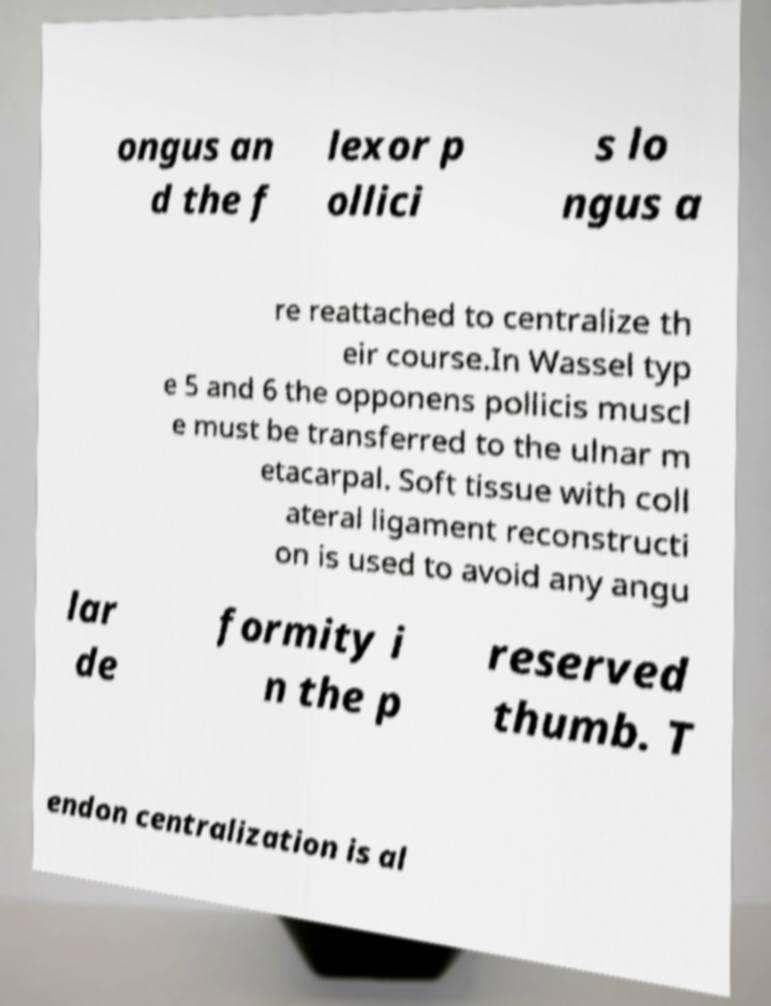I need the written content from this picture converted into text. Can you do that? ongus an d the f lexor p ollici s lo ngus a re reattached to centralize th eir course.In Wassel typ e 5 and 6 the opponens pollicis muscl e must be transferred to the ulnar m etacarpal. Soft tissue with coll ateral ligament reconstructi on is used to avoid any angu lar de formity i n the p reserved thumb. T endon centralization is al 